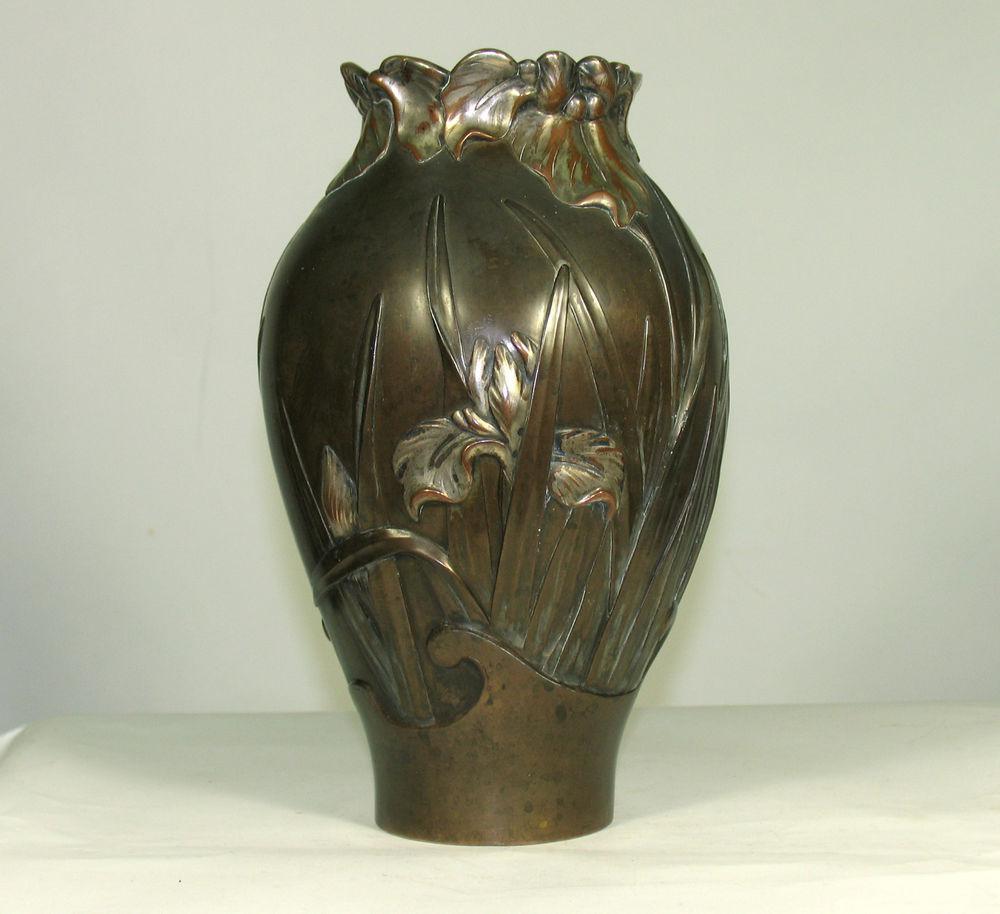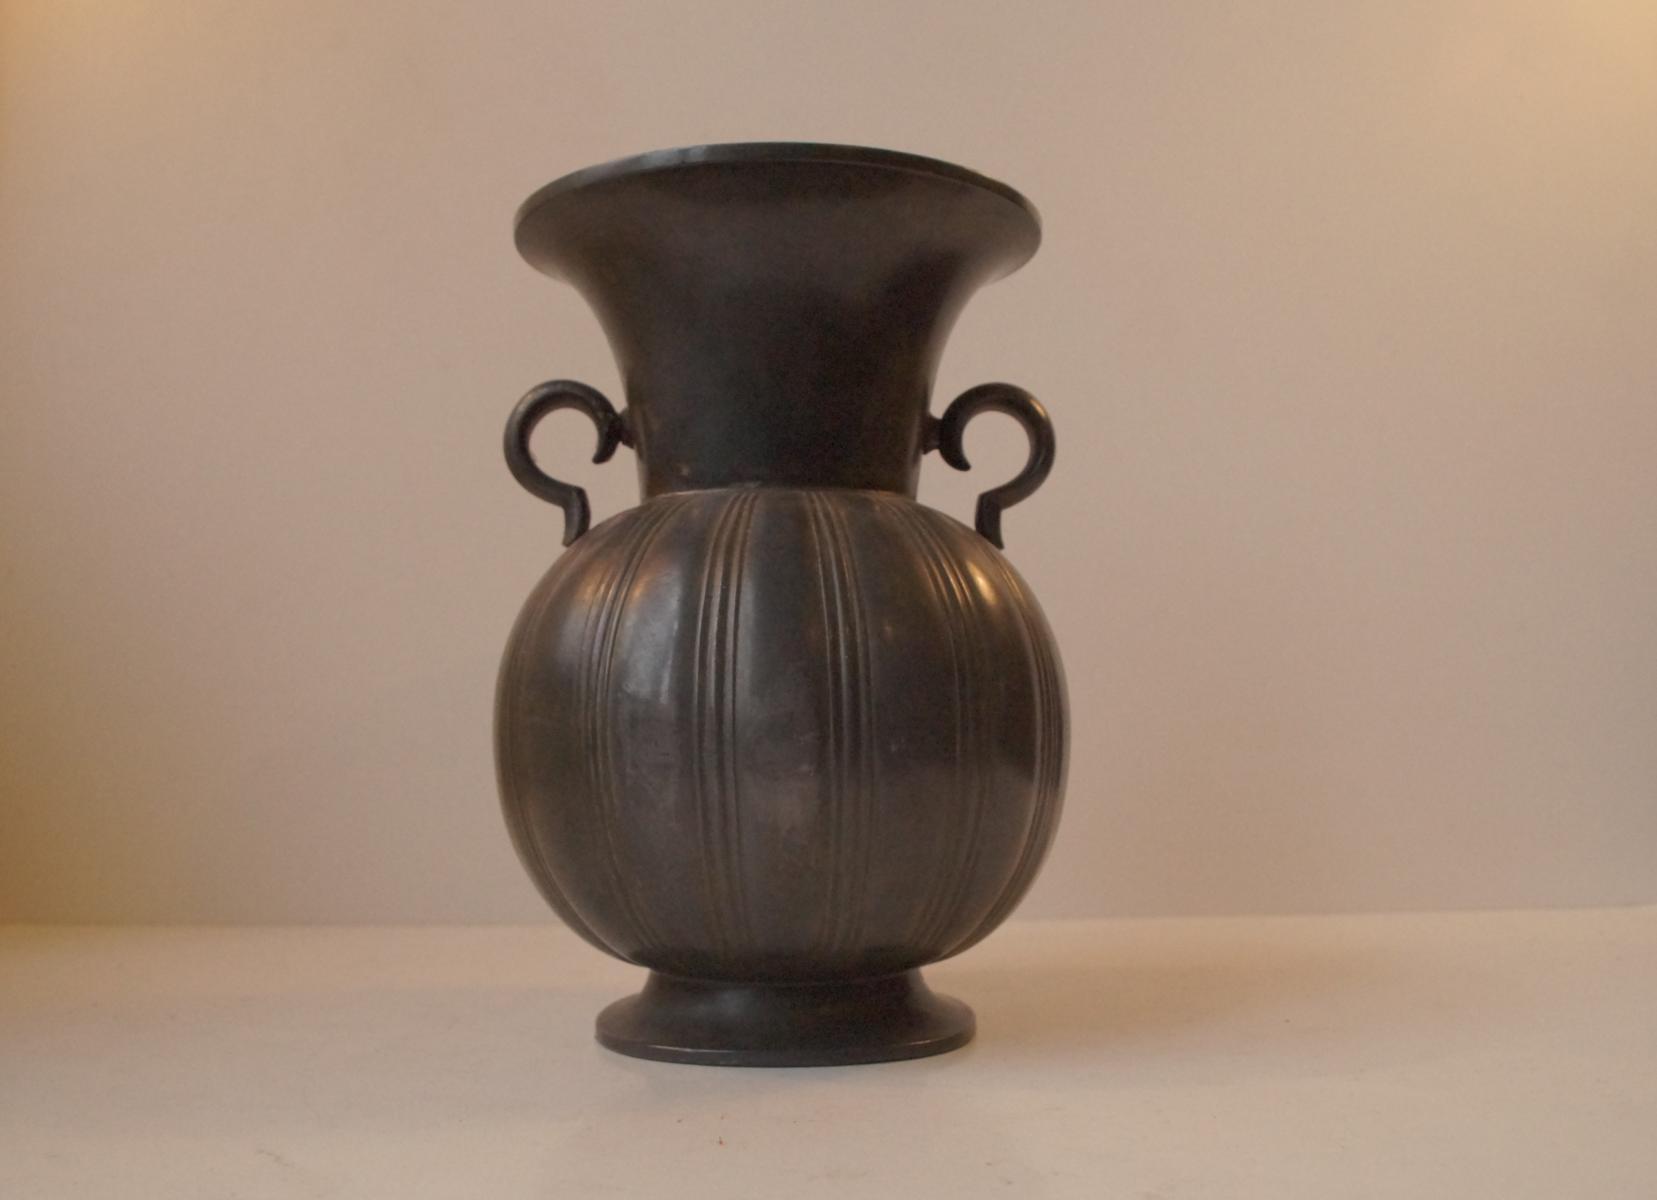The first image is the image on the left, the second image is the image on the right. Evaluate the accuracy of this statement regarding the images: "One of the vases has a round opening, and at least one of the vases has a rectangular opening.". Is it true? Answer yes or no. No. The first image is the image on the left, the second image is the image on the right. Examine the images to the left and right. Is the description "An image includes a vase that tapers to a narrower base from a flat top and has a foliage-themed design on it." accurate? Answer yes or no. No. 